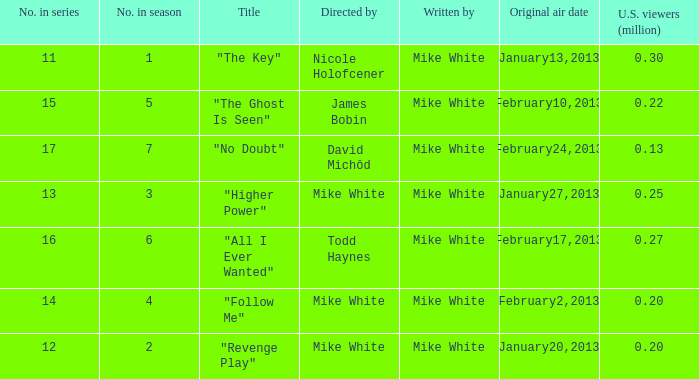How many episodes in the serie were title "the key" 1.0. 